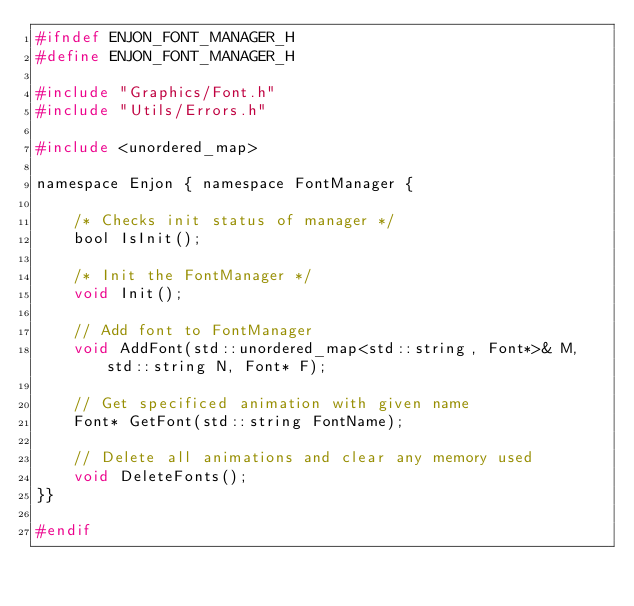<code> <loc_0><loc_0><loc_500><loc_500><_C_>#ifndef ENJON_FONT_MANAGER_H
#define ENJON_FONT_MANAGER_H

#include "Graphics/Font.h"
#include "Utils/Errors.h"

#include <unordered_map>

namespace Enjon { namespace FontManager {

	/* Checks init status of manager */
	bool IsInit();

	/* Init the FontManager */
	void Init();

	// Add font to FontManager 
	void AddFont(std::unordered_map<std::string, Font*>& M, std::string N, Font* F);

	// Get specificed animation with given name
	Font* GetFont(std::string FontName);

	// Delete all animations and clear any memory used
	void DeleteFonts();
}}

#endif




</code> 